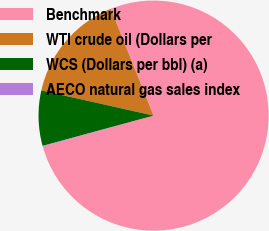Convert chart. <chart><loc_0><loc_0><loc_500><loc_500><pie_chart><fcel>Benchmark<fcel>WTI crude oil (Dollars per<fcel>WCS (Dollars per bbl) (a)<fcel>AECO natural gas sales index<nl><fcel>76.73%<fcel>15.42%<fcel>7.76%<fcel>0.09%<nl></chart> 